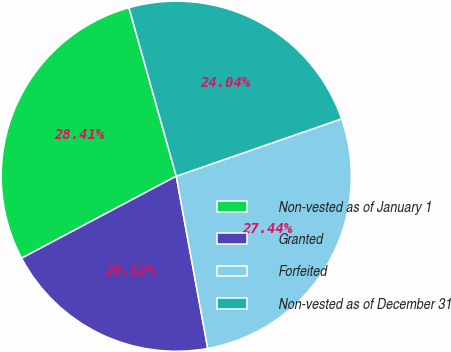<chart> <loc_0><loc_0><loc_500><loc_500><pie_chart><fcel>Non-vested as of January 1<fcel>Granted<fcel>Forfeited<fcel>Non-vested as of December 31<nl><fcel>28.41%<fcel>20.12%<fcel>27.44%<fcel>24.04%<nl></chart> 